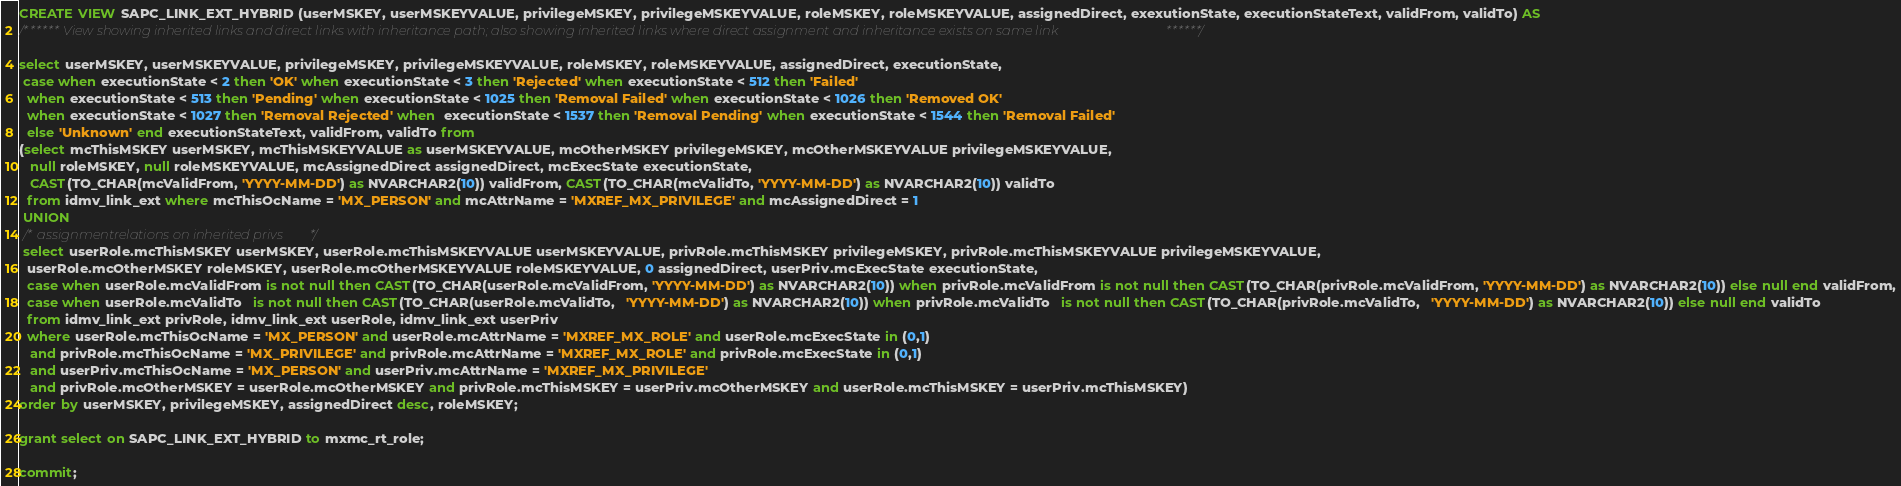Convert code to text. <code><loc_0><loc_0><loc_500><loc_500><_SQL_>CREATE VIEW SAPC_LINK_EXT_HYBRID (userMSKEY, userMSKEYVALUE, privilegeMSKEY, privilegeMSKEYVALUE, roleMSKEY, roleMSKEYVALUE, assignedDirect, exexutionState, executionStateText, validFrom, validTo) AS
/****** View showing inherited links and direct links with inheritance path; also showing inherited links where direct assignment and inheritance exists on same link ******/

select userMSKEY, userMSKEYVALUE, privilegeMSKEY, privilegeMSKEYVALUE, roleMSKEY, roleMSKEYVALUE, assignedDirect, executionState,
 case when executionState < 2 then 'OK' when executionState < 3 then 'Rejected' when executionState < 512 then 'Failed'
  when executionState < 513 then 'Pending' when executionState < 1025 then 'Removal Failed' when executionState < 1026 then 'Removed OK'
  when executionState < 1027 then 'Removal Rejected' when  executionState < 1537 then 'Removal Pending' when executionState < 1544 then 'Removal Failed'
  else 'Unknown' end executionStateText, validFrom, validTo from
(select mcThisMSKEY userMSKEY, mcThisMSKEYVALUE as userMSKEYVALUE, mcOtherMSKEY privilegeMSKEY, mcOtherMSKEYVALUE privilegeMSKEYVALUE,
   null roleMSKEY, null roleMSKEYVALUE, mcAssignedDirect assignedDirect, mcExecState executionState,
   CAST(TO_CHAR(mcValidFrom, 'YYYY-MM-DD') as NVARCHAR2(10)) validFrom, CAST(TO_CHAR(mcValidTo, 'YYYY-MM-DD') as NVARCHAR2(10)) validTo
  from idmv_link_ext where mcThisOcName = 'MX_PERSON' and mcAttrName = 'MXREF_MX_PRIVILEGE' and mcAssignedDirect = 1
 UNION
 /* assignmentrelations on inherited privs */
 select userRole.mcThisMSKEY userMSKEY, userRole.mcThisMSKEYVALUE userMSKEYVALUE, privRole.mcThisMSKEY privilegeMSKEY, privRole.mcThisMSKEYVALUE privilegeMSKEYVALUE,
  userRole.mcOtherMSKEY roleMSKEY, userRole.mcOtherMSKEYVALUE roleMSKEYVALUE, 0 assignedDirect, userPriv.mcExecState executionState,
  case when userRole.mcValidFrom is not null then CAST(TO_CHAR(userRole.mcValidFrom, 'YYYY-MM-DD') as NVARCHAR2(10)) when privRole.mcValidFrom is not null then CAST(TO_CHAR(privRole.mcValidFrom, 'YYYY-MM-DD') as NVARCHAR2(10)) else null end validFrom,
  case when userRole.mcValidTo   is not null then CAST(TO_CHAR(userRole.mcValidTo,   'YYYY-MM-DD') as NVARCHAR2(10)) when privRole.mcValidTo   is not null then CAST(TO_CHAR(privRole.mcValidTo,   'YYYY-MM-DD') as NVARCHAR2(10)) else null end validTo
  from idmv_link_ext privRole, idmv_link_ext userRole, idmv_link_ext userPriv
  where userRole.mcThisOcName = 'MX_PERSON' and userRole.mcAttrName = 'MXREF_MX_ROLE' and userRole.mcExecState in (0,1)
   and privRole.mcThisOcName = 'MX_PRIVILEGE' and privRole.mcAttrName = 'MXREF_MX_ROLE' and privRole.mcExecState in (0,1)
   and userPriv.mcThisOcName = 'MX_PERSON' and userPriv.mcAttrName = 'MXREF_MX_PRIVILEGE'
   and privRole.mcOtherMSKEY = userRole.mcOtherMSKEY and privRole.mcThisMSKEY = userPriv.mcOtherMSKEY and userRole.mcThisMSKEY = userPriv.mcThisMSKEY)
order by userMSKEY, privilegeMSKEY, assignedDirect desc, roleMSKEY;

grant select on SAPC_LINK_EXT_HYBRID to mxmc_rt_role;

commit;
</code> 